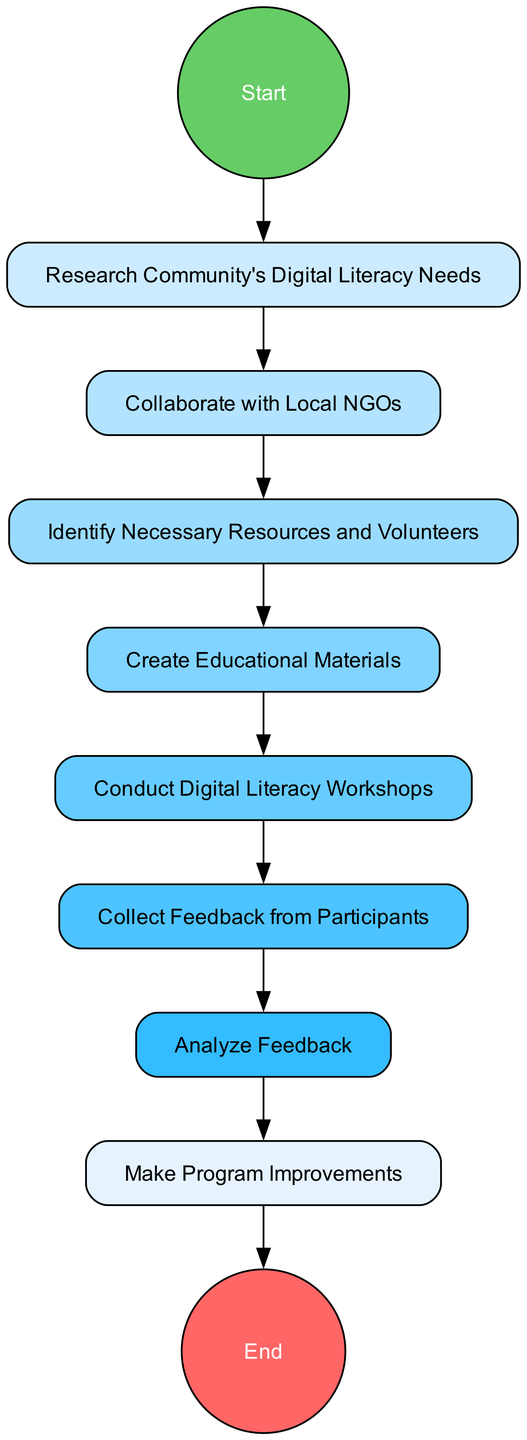What is the total number of nodes in this diagram? Counting the nodes listed in the data, we see there are 10 nodes. This includes the start event, 8 activities, and the end event.
Answer: 10 What is the first activity in the process? The first activity after the start event is "Research Community's Digital Literacy Needs." This is identified by looking at the transition from the start node to the first activity node in the flow.
Answer: Research Community's Digital Literacy Needs How many transitions lead from one activity to another? There are 9 transitions indicated in the data that define the flow from the start, through each activity, and finally to the end. Each transition connects nodes directly, showing the order of activities.
Answer: 9 What activity follows "Collect Feedback from Participants"? The next activity in the diagram after "Collect Feedback from Participants" is "Analyze Feedback," which can be determined by looking at the direct transition from one activity to the next in the flow.
Answer: Analyze Feedback How many activities are there in total? There are 8 activities outlined in the data. These activities appear between the start and end events, each contributing to the outreach program as indicated.
Answer: 8 What node connects "Collaborate with Local NGOs" to "Identify Necessary Resources and Volunteers"? The connection from "Collaborate with Local NGOs" to "Identify Necessary Resources and Volunteers" is established through a direct transition in the flow diagram that outlines the steps of the process.
Answer: Identify Necessary Resources and Volunteers What is the last activity performed before the program ends? The last activity before reaching the end event is "Make Program Improvements." This can be found by tracing the transitions from the last activity back to the end event.
Answer: Make Program Improvements What is the significance of the start event in this diagram? The start event signifies the beginning of the process for the community outreach program, serving as the initial point before any activities commence.
Answer: Starting point 